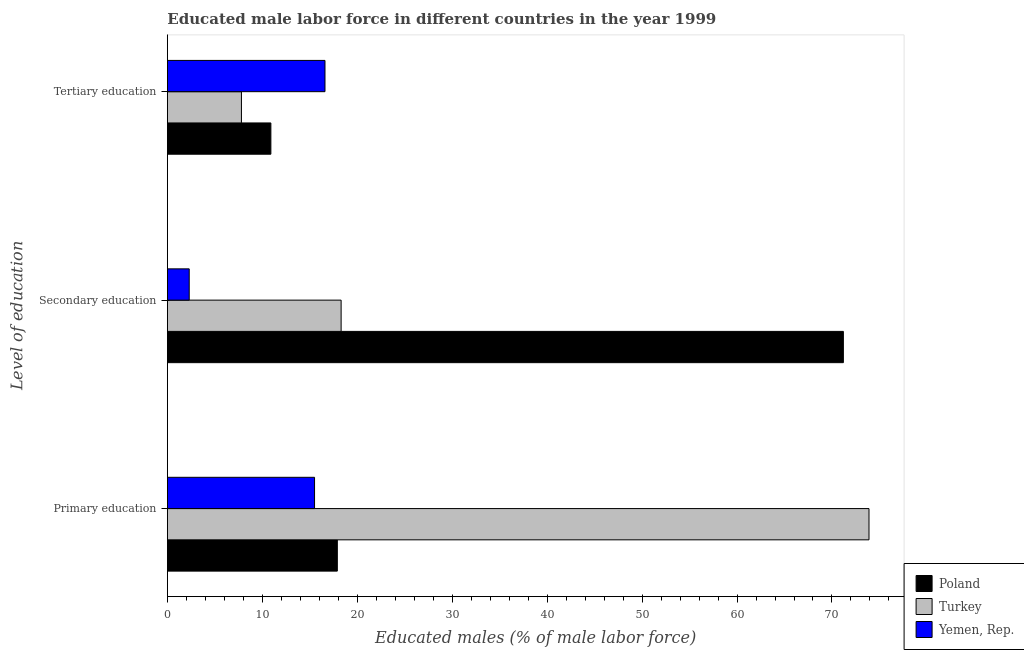Are the number of bars per tick equal to the number of legend labels?
Your response must be concise. Yes. What is the percentage of male labor force who received secondary education in Turkey?
Offer a terse response. 18.3. Across all countries, what is the maximum percentage of male labor force who received secondary education?
Ensure brevity in your answer.  71.2. Across all countries, what is the minimum percentage of male labor force who received primary education?
Keep it short and to the point. 15.5. In which country was the percentage of male labor force who received tertiary education maximum?
Provide a succinct answer. Yemen, Rep. In which country was the percentage of male labor force who received secondary education minimum?
Your response must be concise. Yemen, Rep. What is the total percentage of male labor force who received primary education in the graph?
Your answer should be very brief. 107.3. What is the difference between the percentage of male labor force who received primary education in Yemen, Rep. and that in Turkey?
Your answer should be compact. -58.4. What is the difference between the percentage of male labor force who received secondary education in Poland and the percentage of male labor force who received tertiary education in Yemen, Rep.?
Provide a short and direct response. 54.6. What is the average percentage of male labor force who received primary education per country?
Ensure brevity in your answer.  35.77. What is the difference between the percentage of male labor force who received secondary education and percentage of male labor force who received primary education in Yemen, Rep.?
Your response must be concise. -13.2. What is the ratio of the percentage of male labor force who received tertiary education in Poland to that in Yemen, Rep.?
Provide a succinct answer. 0.66. What is the difference between the highest and the second highest percentage of male labor force who received secondary education?
Give a very brief answer. 52.9. What is the difference between the highest and the lowest percentage of male labor force who received secondary education?
Make the answer very short. 68.9. What does the 1st bar from the top in Primary education represents?
Your answer should be compact. Yemen, Rep. What does the 3rd bar from the bottom in Primary education represents?
Ensure brevity in your answer.  Yemen, Rep. Are the values on the major ticks of X-axis written in scientific E-notation?
Offer a very short reply. No. Does the graph contain any zero values?
Make the answer very short. No. How many legend labels are there?
Your response must be concise. 3. What is the title of the graph?
Make the answer very short. Educated male labor force in different countries in the year 1999. Does "Sudan" appear as one of the legend labels in the graph?
Keep it short and to the point. No. What is the label or title of the X-axis?
Provide a succinct answer. Educated males (% of male labor force). What is the label or title of the Y-axis?
Make the answer very short. Level of education. What is the Educated males (% of male labor force) of Poland in Primary education?
Keep it short and to the point. 17.9. What is the Educated males (% of male labor force) in Turkey in Primary education?
Your answer should be very brief. 73.9. What is the Educated males (% of male labor force) of Poland in Secondary education?
Offer a terse response. 71.2. What is the Educated males (% of male labor force) of Turkey in Secondary education?
Make the answer very short. 18.3. What is the Educated males (% of male labor force) of Yemen, Rep. in Secondary education?
Keep it short and to the point. 2.3. What is the Educated males (% of male labor force) in Poland in Tertiary education?
Offer a very short reply. 10.9. What is the Educated males (% of male labor force) of Turkey in Tertiary education?
Offer a very short reply. 7.8. What is the Educated males (% of male labor force) of Yemen, Rep. in Tertiary education?
Provide a short and direct response. 16.6. Across all Level of education, what is the maximum Educated males (% of male labor force) of Poland?
Your answer should be very brief. 71.2. Across all Level of education, what is the maximum Educated males (% of male labor force) of Turkey?
Provide a short and direct response. 73.9. Across all Level of education, what is the maximum Educated males (% of male labor force) in Yemen, Rep.?
Your answer should be very brief. 16.6. Across all Level of education, what is the minimum Educated males (% of male labor force) in Poland?
Ensure brevity in your answer.  10.9. Across all Level of education, what is the minimum Educated males (% of male labor force) of Turkey?
Provide a short and direct response. 7.8. Across all Level of education, what is the minimum Educated males (% of male labor force) of Yemen, Rep.?
Your response must be concise. 2.3. What is the total Educated males (% of male labor force) of Poland in the graph?
Your answer should be very brief. 100. What is the total Educated males (% of male labor force) of Yemen, Rep. in the graph?
Provide a succinct answer. 34.4. What is the difference between the Educated males (% of male labor force) of Poland in Primary education and that in Secondary education?
Give a very brief answer. -53.3. What is the difference between the Educated males (% of male labor force) of Turkey in Primary education and that in Secondary education?
Your answer should be compact. 55.6. What is the difference between the Educated males (% of male labor force) in Yemen, Rep. in Primary education and that in Secondary education?
Offer a very short reply. 13.2. What is the difference between the Educated males (% of male labor force) of Poland in Primary education and that in Tertiary education?
Ensure brevity in your answer.  7. What is the difference between the Educated males (% of male labor force) in Turkey in Primary education and that in Tertiary education?
Keep it short and to the point. 66.1. What is the difference between the Educated males (% of male labor force) in Poland in Secondary education and that in Tertiary education?
Ensure brevity in your answer.  60.3. What is the difference between the Educated males (% of male labor force) of Turkey in Secondary education and that in Tertiary education?
Ensure brevity in your answer.  10.5. What is the difference between the Educated males (% of male labor force) of Yemen, Rep. in Secondary education and that in Tertiary education?
Keep it short and to the point. -14.3. What is the difference between the Educated males (% of male labor force) of Poland in Primary education and the Educated males (% of male labor force) of Turkey in Secondary education?
Your response must be concise. -0.4. What is the difference between the Educated males (% of male labor force) in Poland in Primary education and the Educated males (% of male labor force) in Yemen, Rep. in Secondary education?
Offer a terse response. 15.6. What is the difference between the Educated males (% of male labor force) of Turkey in Primary education and the Educated males (% of male labor force) of Yemen, Rep. in Secondary education?
Ensure brevity in your answer.  71.6. What is the difference between the Educated males (% of male labor force) of Poland in Primary education and the Educated males (% of male labor force) of Yemen, Rep. in Tertiary education?
Give a very brief answer. 1.3. What is the difference between the Educated males (% of male labor force) in Turkey in Primary education and the Educated males (% of male labor force) in Yemen, Rep. in Tertiary education?
Your answer should be very brief. 57.3. What is the difference between the Educated males (% of male labor force) of Poland in Secondary education and the Educated males (% of male labor force) of Turkey in Tertiary education?
Give a very brief answer. 63.4. What is the difference between the Educated males (% of male labor force) in Poland in Secondary education and the Educated males (% of male labor force) in Yemen, Rep. in Tertiary education?
Your response must be concise. 54.6. What is the average Educated males (% of male labor force) in Poland per Level of education?
Provide a short and direct response. 33.33. What is the average Educated males (% of male labor force) in Turkey per Level of education?
Your response must be concise. 33.33. What is the average Educated males (% of male labor force) of Yemen, Rep. per Level of education?
Offer a very short reply. 11.47. What is the difference between the Educated males (% of male labor force) of Poland and Educated males (% of male labor force) of Turkey in Primary education?
Keep it short and to the point. -56. What is the difference between the Educated males (% of male labor force) in Poland and Educated males (% of male labor force) in Yemen, Rep. in Primary education?
Offer a terse response. 2.4. What is the difference between the Educated males (% of male labor force) of Turkey and Educated males (% of male labor force) of Yemen, Rep. in Primary education?
Offer a terse response. 58.4. What is the difference between the Educated males (% of male labor force) in Poland and Educated males (% of male labor force) in Turkey in Secondary education?
Ensure brevity in your answer.  52.9. What is the difference between the Educated males (% of male labor force) of Poland and Educated males (% of male labor force) of Yemen, Rep. in Secondary education?
Your answer should be very brief. 68.9. What is the difference between the Educated males (% of male labor force) in Turkey and Educated males (% of male labor force) in Yemen, Rep. in Secondary education?
Provide a succinct answer. 16. What is the difference between the Educated males (% of male labor force) in Poland and Educated males (% of male labor force) in Yemen, Rep. in Tertiary education?
Your response must be concise. -5.7. What is the difference between the Educated males (% of male labor force) of Turkey and Educated males (% of male labor force) of Yemen, Rep. in Tertiary education?
Provide a short and direct response. -8.8. What is the ratio of the Educated males (% of male labor force) in Poland in Primary education to that in Secondary education?
Your answer should be very brief. 0.25. What is the ratio of the Educated males (% of male labor force) in Turkey in Primary education to that in Secondary education?
Keep it short and to the point. 4.04. What is the ratio of the Educated males (% of male labor force) in Yemen, Rep. in Primary education to that in Secondary education?
Keep it short and to the point. 6.74. What is the ratio of the Educated males (% of male labor force) of Poland in Primary education to that in Tertiary education?
Give a very brief answer. 1.64. What is the ratio of the Educated males (% of male labor force) of Turkey in Primary education to that in Tertiary education?
Your response must be concise. 9.47. What is the ratio of the Educated males (% of male labor force) in Yemen, Rep. in Primary education to that in Tertiary education?
Your response must be concise. 0.93. What is the ratio of the Educated males (% of male labor force) of Poland in Secondary education to that in Tertiary education?
Offer a terse response. 6.53. What is the ratio of the Educated males (% of male labor force) in Turkey in Secondary education to that in Tertiary education?
Give a very brief answer. 2.35. What is the ratio of the Educated males (% of male labor force) in Yemen, Rep. in Secondary education to that in Tertiary education?
Your answer should be very brief. 0.14. What is the difference between the highest and the second highest Educated males (% of male labor force) of Poland?
Keep it short and to the point. 53.3. What is the difference between the highest and the second highest Educated males (% of male labor force) in Turkey?
Offer a very short reply. 55.6. What is the difference between the highest and the second highest Educated males (% of male labor force) of Yemen, Rep.?
Provide a succinct answer. 1.1. What is the difference between the highest and the lowest Educated males (% of male labor force) of Poland?
Ensure brevity in your answer.  60.3. What is the difference between the highest and the lowest Educated males (% of male labor force) in Turkey?
Give a very brief answer. 66.1. 